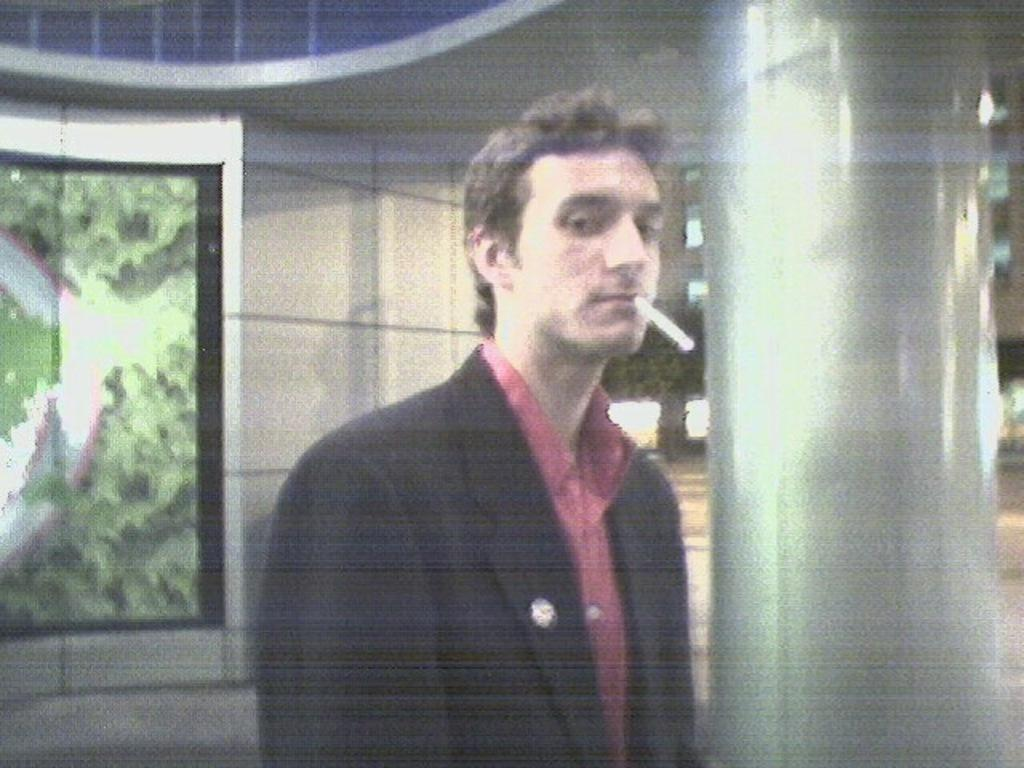What type of view is depicted in the image? The image shows the inner view of a building. Can you describe the person in the image? There is a person standing in the image, and they have a cigarette in their mouth. What architectural feature can be seen on the right side of the image? There is a pillar on the right side of the image. What type of oven is visible in the image? There is no oven present in the image. How does the person's cigarette contribute to pollution in the image? The image does not show any pollution or its causes, and the person's cigarette is not mentioned in this context. --- Facts: 1. There is a car in the image. 2. The car is parked on the street. 3. There are trees on the left side of the image. 4. The sky is visible at the top of the image. Absurd Topics: parrot, sand, dance Conversation: What is the main subject of the image? The main subject of the image is a car. Where is the car located in the image? The car is parked on the street. What type of vegetation can be seen on the left side of the image? There are trees on the left side of the image. What is visible at the top of the image? The sky is visible at the top of the image. Reasoning: Let's think step by step in order to produce the conversation. We start by identifying the main subject of the image, which is the car. Then, we describe the car's location, noting that it is parked on the street. Next, we mention the type of vegetation visible in the image, which are trees on the left side. Finally, we describe the sky's condition, which is visible at the top of the image. Absurd Question/Answer: Can you tell me how many parrots are sitting on the car in the image? There are no parrots present in the image; it features a car parked on the street. What type of dance is being performed in the image? There is no dance or dancing activity depicted in the image. 